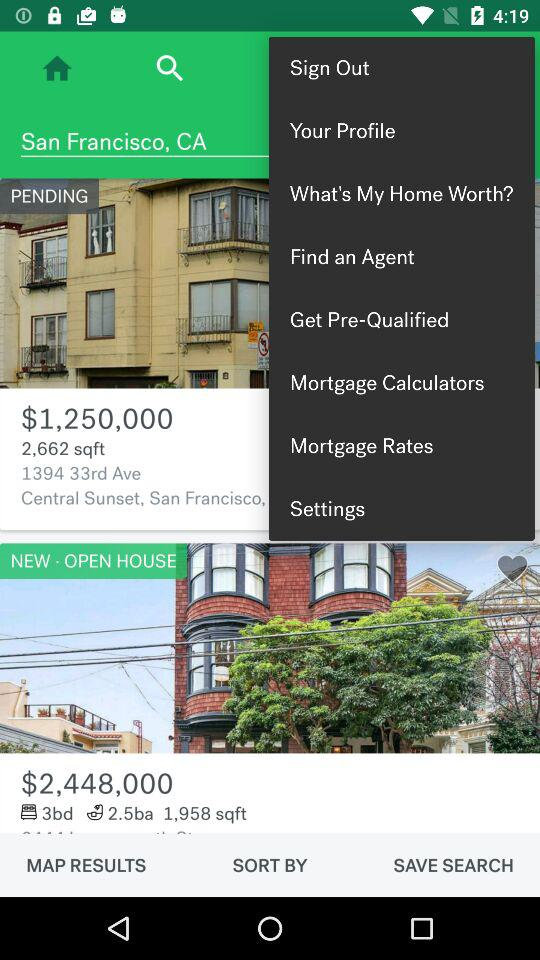What is the address of the house with a pending status? The address of the house is 1394 33rd Avenue, Central Sunset, San Francisco. 